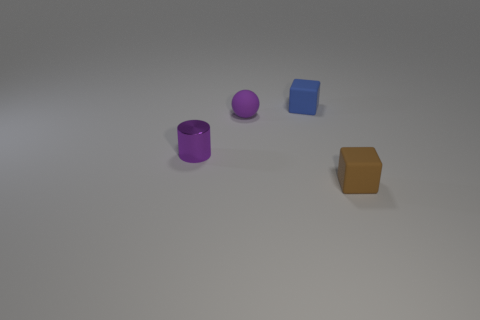What size is the blue object that is made of the same material as the brown block? The blue object in the image that appears to be made of the same material as the brown block seems small relative to the context of the image, with a simple, solid appearance indicating it might be lightweight and easy to handle. 